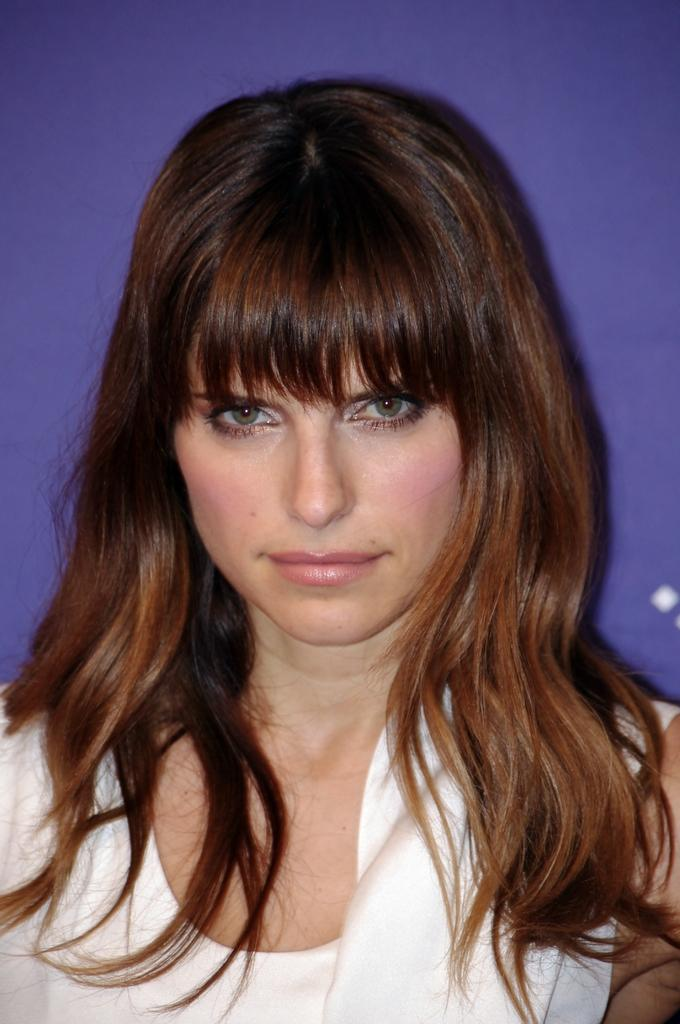What is the woman in the image wearing? The woman in the image is wearing a white dress. Can you describe any other objects or features in the image? Yes, there are two white objects that look like dots on the right side of the image. What color is the background of the image? The background of the image is blue. What type of wood can be seen in the image? There is no wood present in the image. Can you describe the shoe that the woman is wearing in the image? The woman is not wearing a shoe in the image; she is wearing a white dress. 